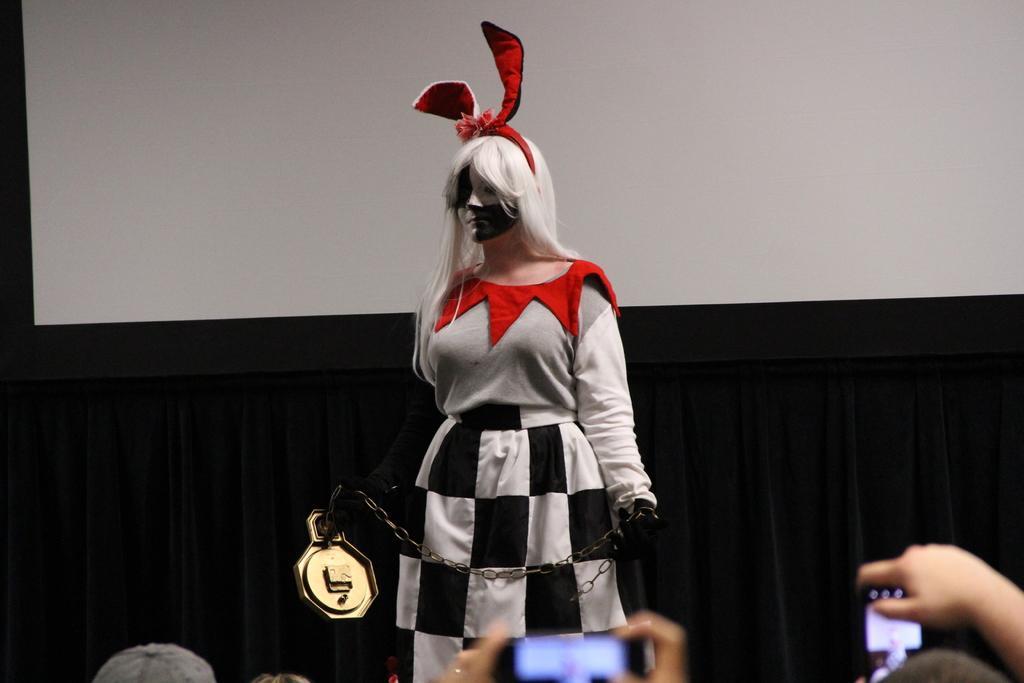Please provide a concise description of this image. In this image, we can see a person wearing a costume and holding a chain with object. At the bottom, we can see people hands and screen. Background there is a screen and curtain. 